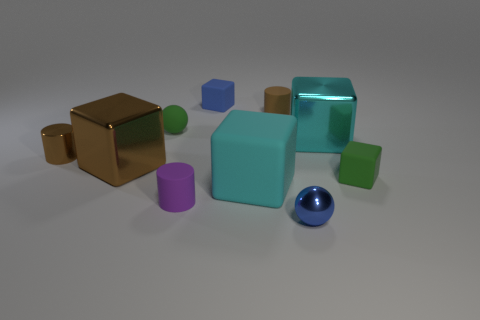Subtract all brown blocks. How many blocks are left? 4 Subtract all small green matte cubes. How many cubes are left? 4 Subtract all red blocks. Subtract all purple balls. How many blocks are left? 5 Subtract all spheres. How many objects are left? 8 Subtract all tiny gray metal cylinders. Subtract all large brown blocks. How many objects are left? 9 Add 4 brown matte things. How many brown matte things are left? 5 Add 3 tiny blue balls. How many tiny blue balls exist? 4 Subtract 0 gray blocks. How many objects are left? 10 